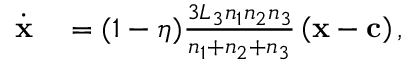Convert formula to latex. <formula><loc_0><loc_0><loc_500><loc_500>\begin{array} { r l } { \dot { x } } & = ( 1 - \eta ) \frac { 3 L _ { 3 } n _ { 1 } n _ { 2 } n _ { 3 } } { n _ { 1 } + n _ { 2 } + n _ { 3 } } \left ( x - c \right ) , } \end{array}</formula> 